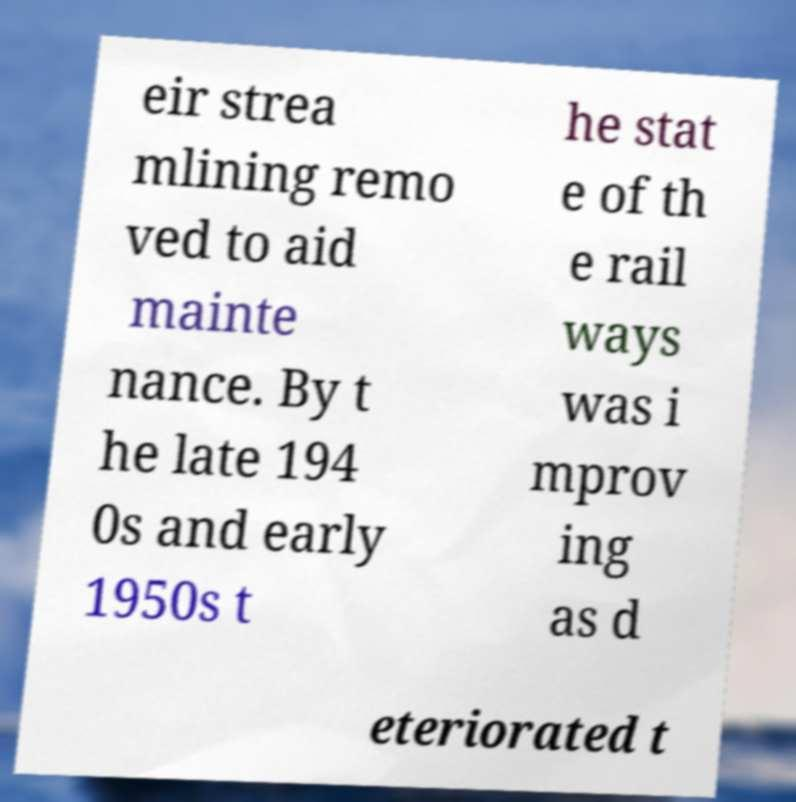There's text embedded in this image that I need extracted. Can you transcribe it verbatim? eir strea mlining remo ved to aid mainte nance. By t he late 194 0s and early 1950s t he stat e of th e rail ways was i mprov ing as d eteriorated t 